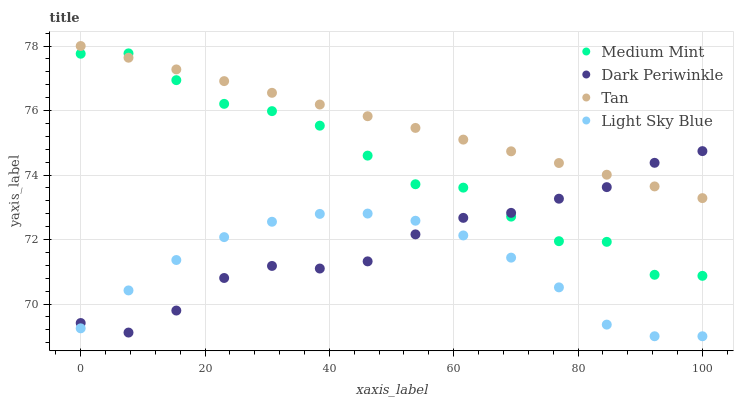Does Light Sky Blue have the minimum area under the curve?
Answer yes or no. Yes. Does Tan have the maximum area under the curve?
Answer yes or no. Yes. Does Tan have the minimum area under the curve?
Answer yes or no. No. Does Light Sky Blue have the maximum area under the curve?
Answer yes or no. No. Is Tan the smoothest?
Answer yes or no. Yes. Is Medium Mint the roughest?
Answer yes or no. Yes. Is Light Sky Blue the smoothest?
Answer yes or no. No. Is Light Sky Blue the roughest?
Answer yes or no. No. Does Light Sky Blue have the lowest value?
Answer yes or no. Yes. Does Tan have the lowest value?
Answer yes or no. No. Does Tan have the highest value?
Answer yes or no. Yes. Does Light Sky Blue have the highest value?
Answer yes or no. No. Is Light Sky Blue less than Medium Mint?
Answer yes or no. Yes. Is Medium Mint greater than Light Sky Blue?
Answer yes or no. Yes. Does Dark Periwinkle intersect Tan?
Answer yes or no. Yes. Is Dark Periwinkle less than Tan?
Answer yes or no. No. Is Dark Periwinkle greater than Tan?
Answer yes or no. No. Does Light Sky Blue intersect Medium Mint?
Answer yes or no. No. 